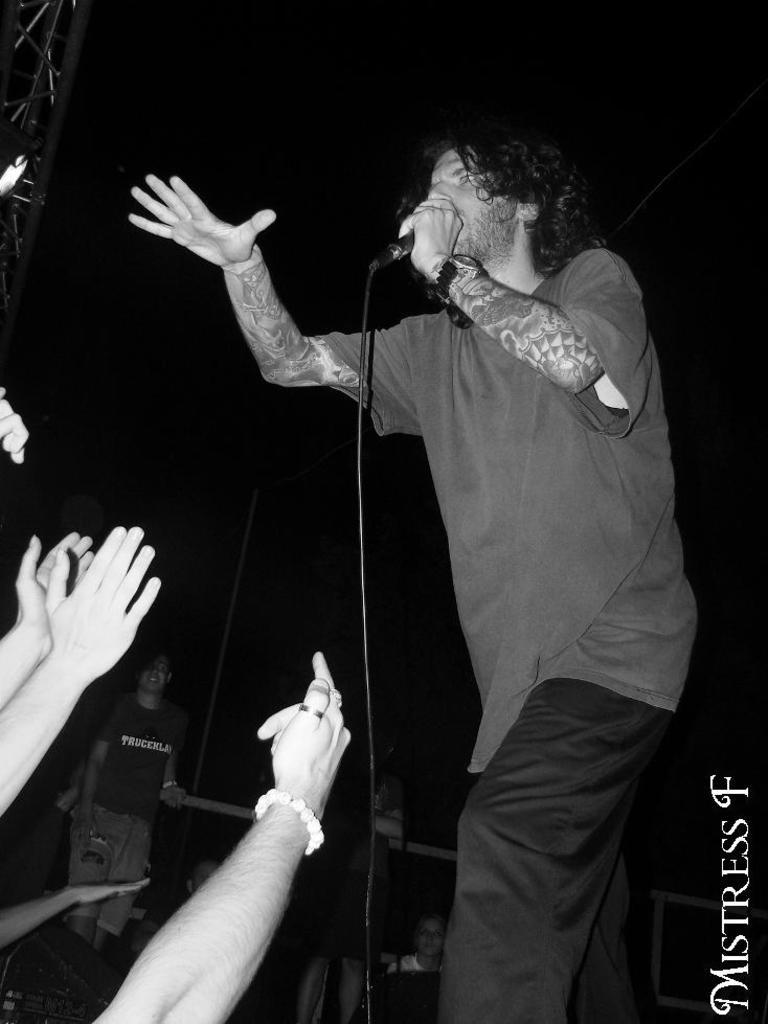What is the person in the image doing? The person is standing and holding a microphone. Can you describe the hands visible on the left side of the image? The hands of people are visible on the left side of the image. What is the color of the background in the image? The background of the image is dark. What type of snake is crawling on the person's shoulder in the image? There is no snake present in the image; the person is holding a microphone. Can you describe the mother's reaction to the person's performance in the image? There is no mother or performance present in the image, so it is not possible to describe a reaction. 